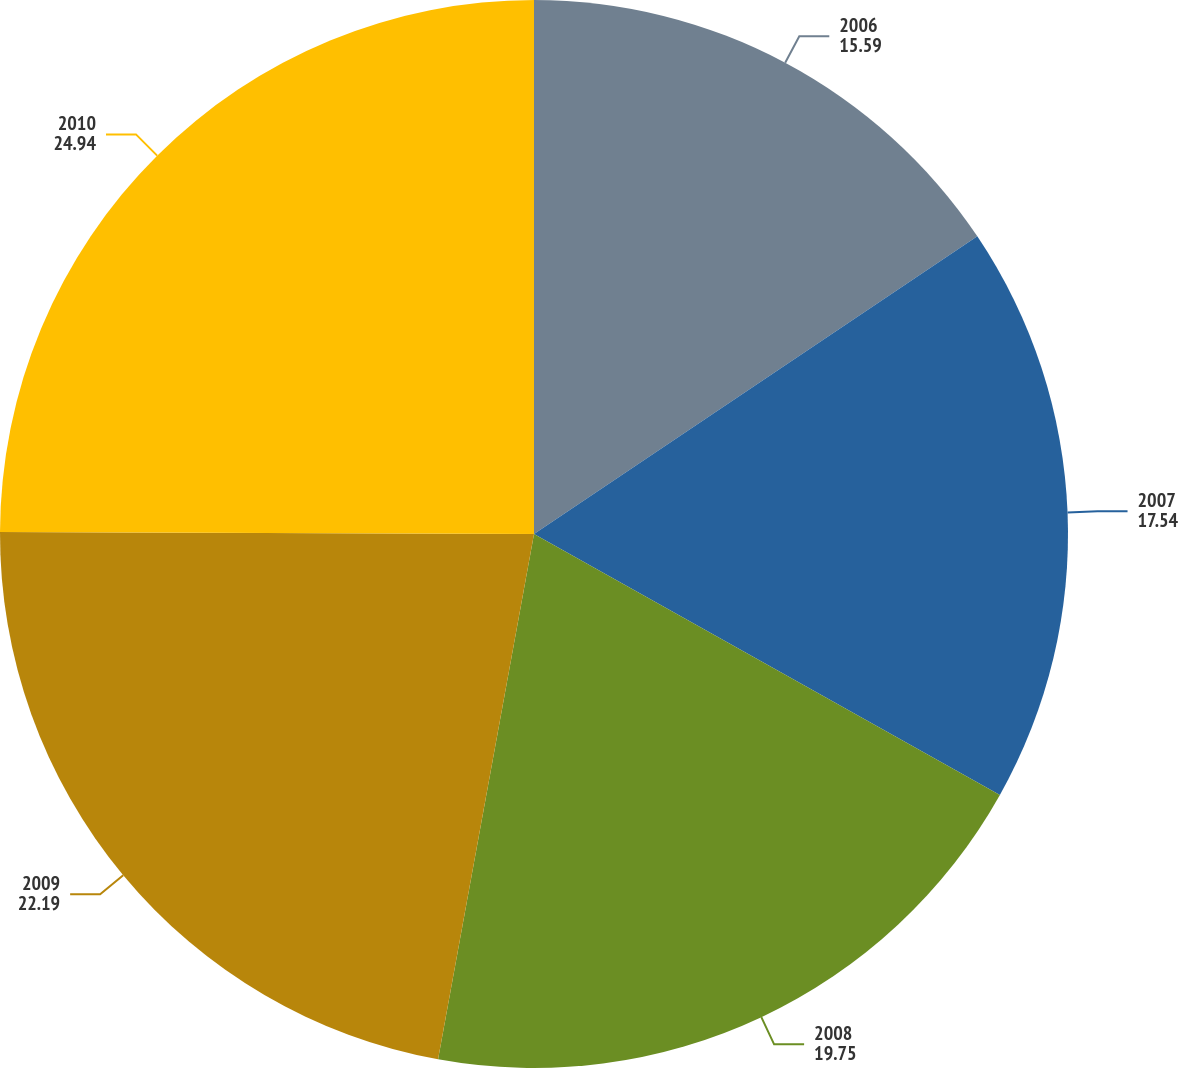Convert chart. <chart><loc_0><loc_0><loc_500><loc_500><pie_chart><fcel>2006<fcel>2007<fcel>2008<fcel>2009<fcel>2010<nl><fcel>15.59%<fcel>17.54%<fcel>19.75%<fcel>22.19%<fcel>24.94%<nl></chart> 